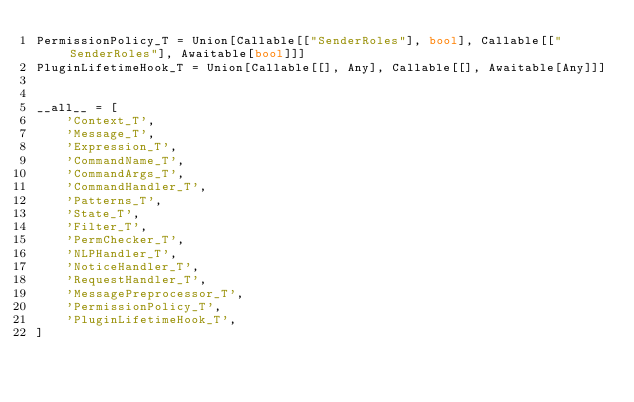Convert code to text. <code><loc_0><loc_0><loc_500><loc_500><_Python_>PermissionPolicy_T = Union[Callable[["SenderRoles"], bool], Callable[["SenderRoles"], Awaitable[bool]]]
PluginLifetimeHook_T = Union[Callable[[], Any], Callable[[], Awaitable[Any]]]


__all__ = [
    'Context_T',
    'Message_T',
    'Expression_T',
    'CommandName_T',
    'CommandArgs_T',
    'CommandHandler_T',
    'Patterns_T',
    'State_T',
    'Filter_T',
    'PermChecker_T',
    'NLPHandler_T',
    'NoticeHandler_T',
    'RequestHandler_T',
    'MessagePreprocessor_T',
    'PermissionPolicy_T',
    'PluginLifetimeHook_T',
]
</code> 